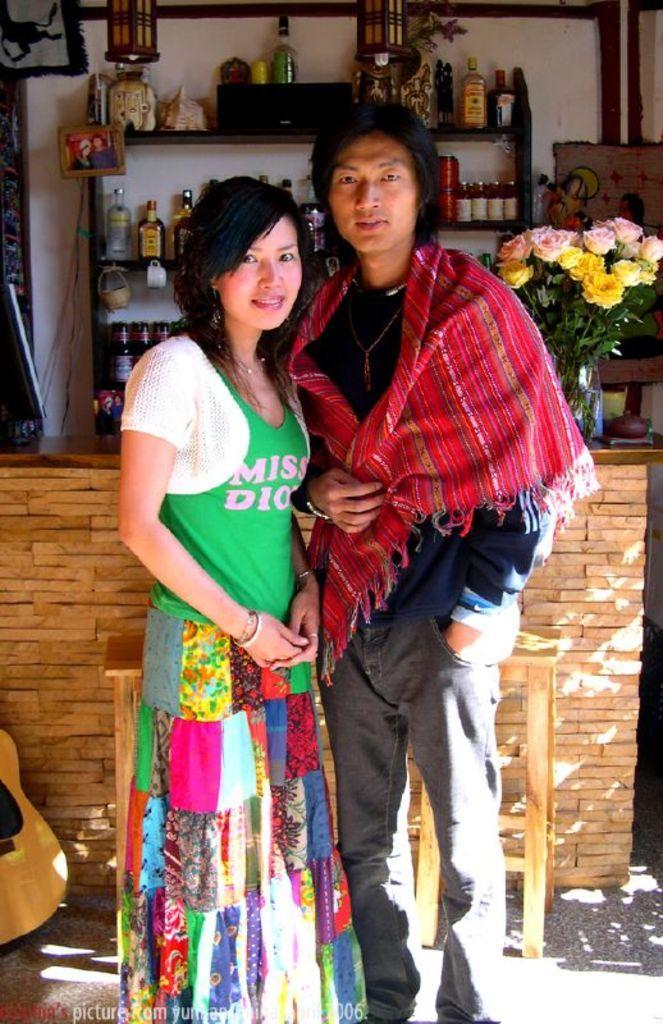Could you give a brief overview of what you see in this image? In this image i can see a man and a woman is standing and smiling together. Behind these people i can see there is a table and a shelf with glass bottles on it. 